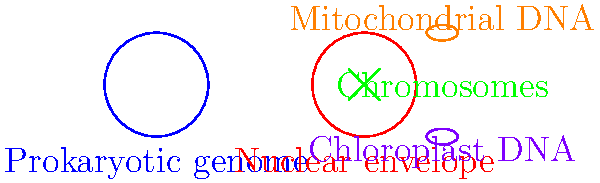Based on the illustration, which key structural difference between prokaryotic and eukaryotic genomes contributes to the increased complexity of gene regulation in eukaryotes? To answer this question, let's analyze the structural differences between prokaryotic and eukaryotic genomes as shown in the illustration:

1. Prokaryotic genome:
   - Represented by a single circular DNA molecule
   - Located directly in the cell's cytoplasm
   - No nuclear membrane or other compartmentalization

2. Eukaryotic genome:
   - Multiple linear chromosomes within a nuclear envelope
   - Presence of organelle DNA (mitochondrial and chloroplast)
   - Compartmentalization due to the nuclear envelope

The key structural difference that contributes to increased complexity of gene regulation in eukaryotes is the presence of a nuclear envelope. This compartmentalization:

a) Separates transcription (which occurs in the nucleus) from translation (which occurs in the cytoplasm)
b) Allows for post-transcriptional modifications of mRNA before it exits the nucleus
c) Enables more complex regulatory mechanisms, such as nuclear transport of regulatory proteins
d) Provides an additional layer of control over gene expression through nuclear pore complexes

The nuclear envelope creates a physical barrier that necessitates more sophisticated regulatory mechanisms for gene expression in eukaryotes compared to the simpler, more direct gene expression processes in prokaryotes.
Answer: Presence of a nuclear envelope 